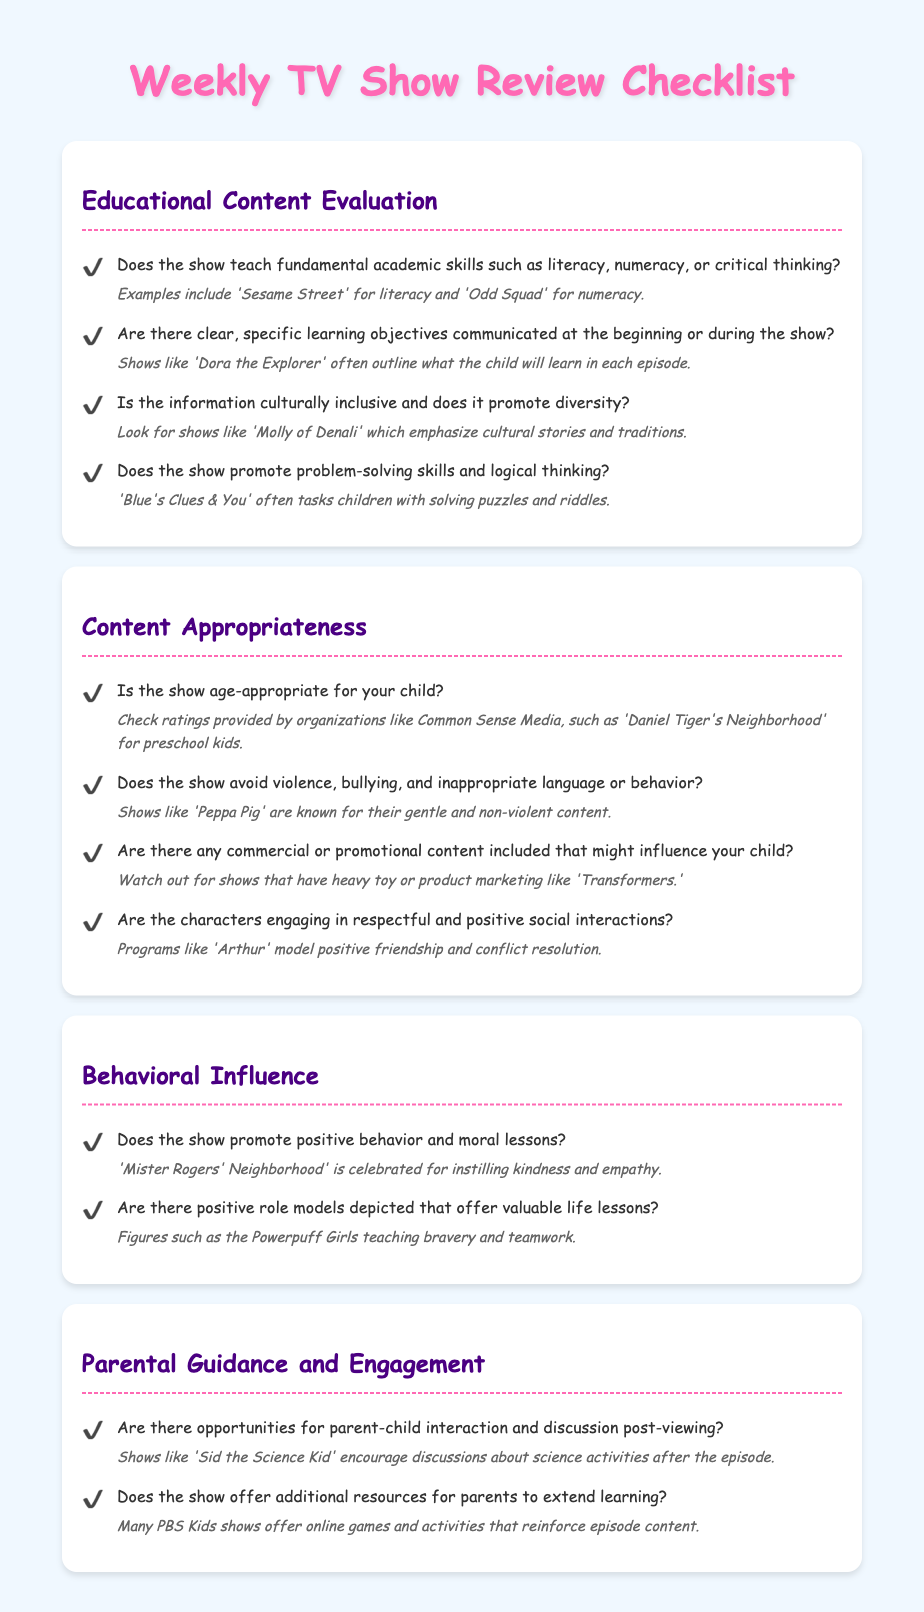Does the show teach academic skills? The checklist specifically asks whether the show teaches fundamental academic skills like literacy or numeracy, as seen in examples provided.
Answer: Yes What characterizes a show’s age-appropriateness? The document mentions that ratings from organizations like Common Sense Media help determine if a show is age-appropriate for a child.
Answer: Ratings Name a show that promotes problem-solving skills. The checklist provides an example of a show that encourages logical thinking and problem-solving through its content.
Answer: Blue's Clues & You What is highlighted in shows like 'Dora the Explorer'? The document illustrates that 'Dora the Explorer' outlines learning objectives at the start or during episodes.
Answer: Learning objectives What type of content should be avoided in children's shows? The checklist specifies that shows should avoid violence, bullying, and inappropriate language or behavior.
Answer: Violence How can shows encourage parent-child interaction? The checklist notes that certain shows provide opportunities for discussion and interaction post-viewing, aiding in learning.
Answer: Discussion opportunities What additional resources might shows provide for parents? The document indicates that many shows offer online games and activities to reinforce educational content for parents and children.
Answer: Online games What lesson does 'Mister Rogers' Neighborhood' instill? The checklist mentions that 'Mister Rogers' Neighborhood' promotes kindness and empathy as core lessons for children.
Answer: Kindness and empathy 